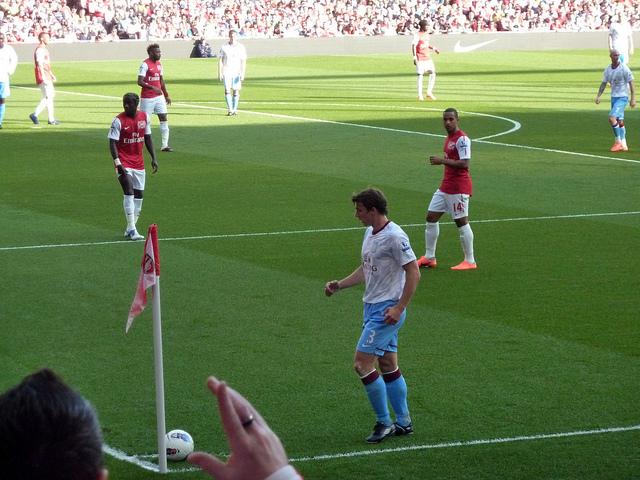What kind of ball are the men using?
Be succinct. Soccer. Who is going to win?
Answer briefly. Red. Are these people playing soccer?
Answer briefly. Yes. 